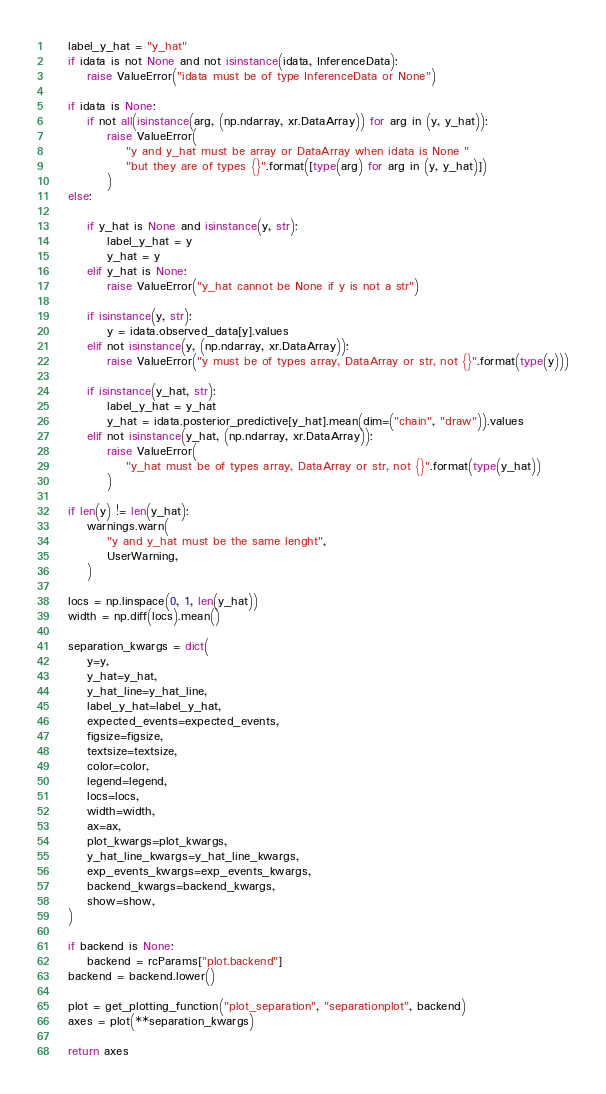<code> <loc_0><loc_0><loc_500><loc_500><_Python_>    label_y_hat = "y_hat"
    if idata is not None and not isinstance(idata, InferenceData):
        raise ValueError("idata must be of type InferenceData or None")

    if idata is None:
        if not all(isinstance(arg, (np.ndarray, xr.DataArray)) for arg in (y, y_hat)):
            raise ValueError(
                "y and y_hat must be array or DataArray when idata is None "
                "but they are of types {}".format([type(arg) for arg in (y, y_hat)])
            )
    else:

        if y_hat is None and isinstance(y, str):
            label_y_hat = y
            y_hat = y
        elif y_hat is None:
            raise ValueError("y_hat cannot be None if y is not a str")

        if isinstance(y, str):
            y = idata.observed_data[y].values
        elif not isinstance(y, (np.ndarray, xr.DataArray)):
            raise ValueError("y must be of types array, DataArray or str, not {}".format(type(y)))

        if isinstance(y_hat, str):
            label_y_hat = y_hat
            y_hat = idata.posterior_predictive[y_hat].mean(dim=("chain", "draw")).values
        elif not isinstance(y_hat, (np.ndarray, xr.DataArray)):
            raise ValueError(
                "y_hat must be of types array, DataArray or str, not {}".format(type(y_hat))
            )

    if len(y) != len(y_hat):
        warnings.warn(
            "y and y_hat must be the same lenght",
            UserWarning,
        )

    locs = np.linspace(0, 1, len(y_hat))
    width = np.diff(locs).mean()

    separation_kwargs = dict(
        y=y,
        y_hat=y_hat,
        y_hat_line=y_hat_line,
        label_y_hat=label_y_hat,
        expected_events=expected_events,
        figsize=figsize,
        textsize=textsize,
        color=color,
        legend=legend,
        locs=locs,
        width=width,
        ax=ax,
        plot_kwargs=plot_kwargs,
        y_hat_line_kwargs=y_hat_line_kwargs,
        exp_events_kwargs=exp_events_kwargs,
        backend_kwargs=backend_kwargs,
        show=show,
    )

    if backend is None:
        backend = rcParams["plot.backend"]
    backend = backend.lower()

    plot = get_plotting_function("plot_separation", "separationplot", backend)
    axes = plot(**separation_kwargs)

    return axes
</code> 